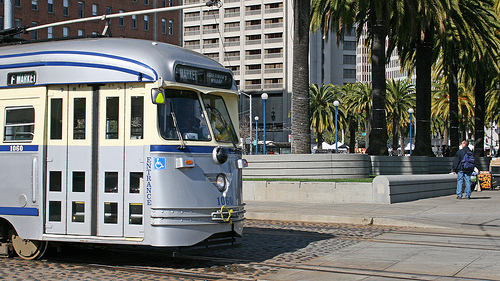<image>
Is there a window behind the car? No. The window is not behind the car. From this viewpoint, the window appears to be positioned elsewhere in the scene. Is the truck in front of the house? Yes. The truck is positioned in front of the house, appearing closer to the camera viewpoint. 